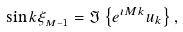<formula> <loc_0><loc_0><loc_500><loc_500>\sin { k } \xi _ { _ { M - 1 } } = \Im \left \{ e ^ { \imath M k } u _ { k } \right \} ,</formula> 